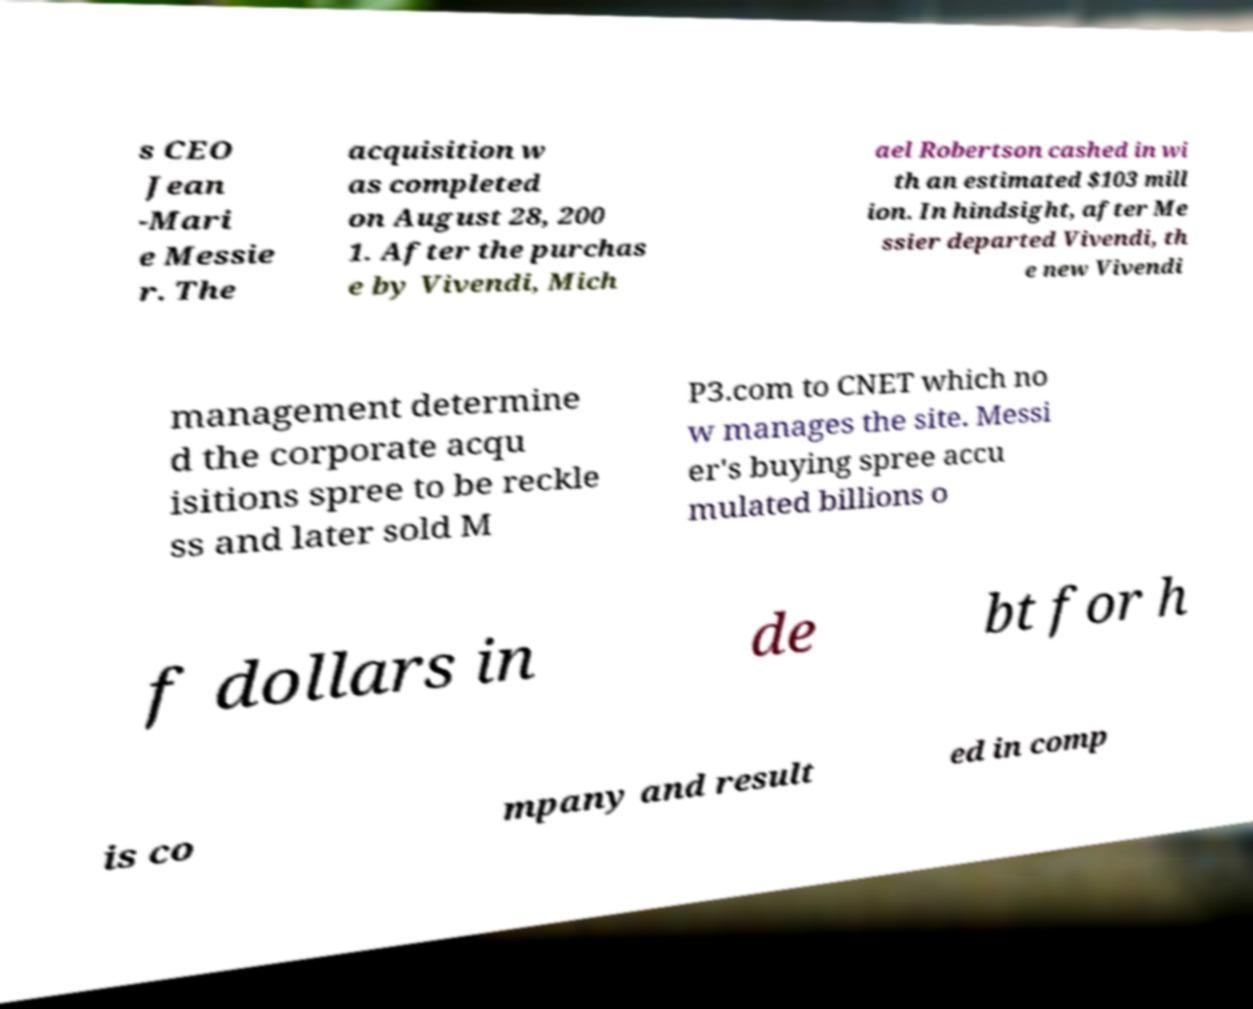Could you extract and type out the text from this image? s CEO Jean -Mari e Messie r. The acquisition w as completed on August 28, 200 1. After the purchas e by Vivendi, Mich ael Robertson cashed in wi th an estimated $103 mill ion. In hindsight, after Me ssier departed Vivendi, th e new Vivendi management determine d the corporate acqu isitions spree to be reckle ss and later sold M P3.com to CNET which no w manages the site. Messi er's buying spree accu mulated billions o f dollars in de bt for h is co mpany and result ed in comp 